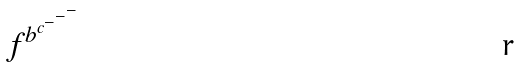<formula> <loc_0><loc_0><loc_500><loc_500>f ^ { b ^ { c ^ { - ^ { - ^ { - } } } } }</formula> 